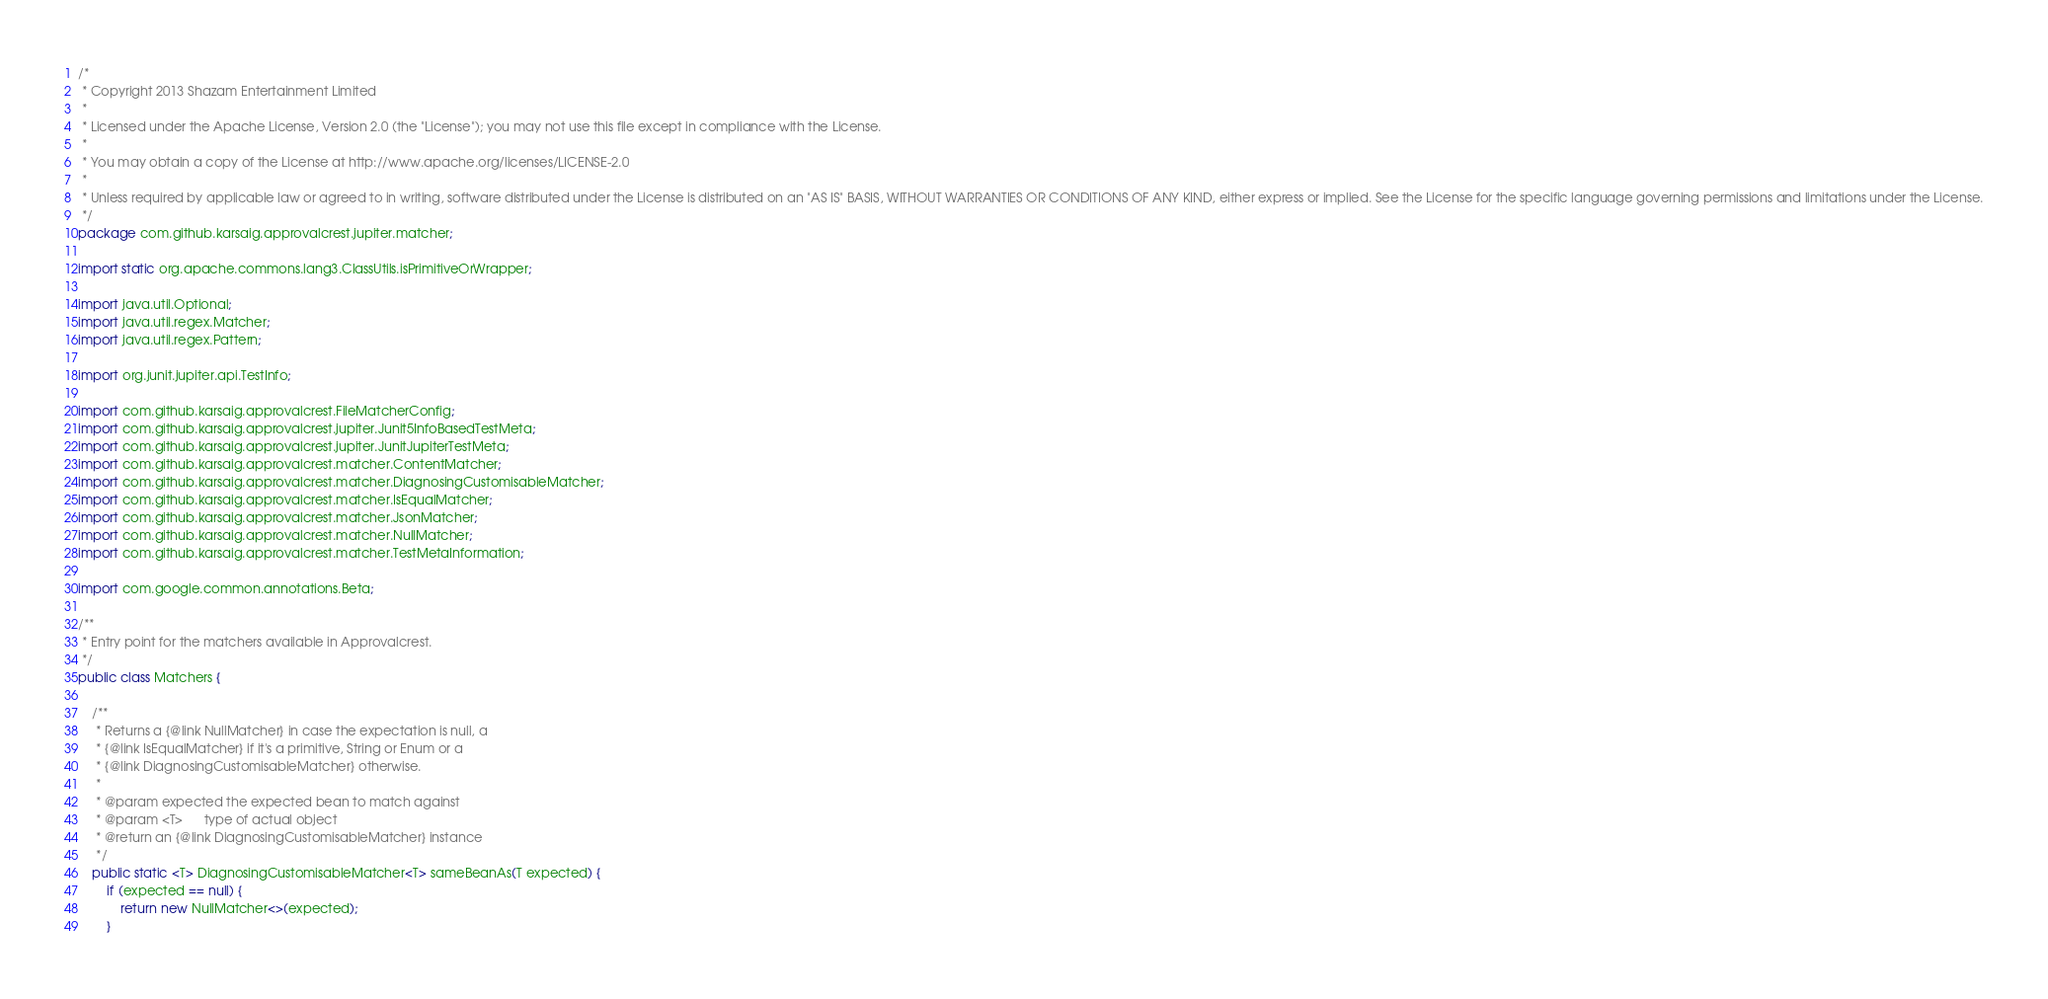<code> <loc_0><loc_0><loc_500><loc_500><_Java_>/*
 * Copyright 2013 Shazam Entertainment Limited
 *
 * Licensed under the Apache License, Version 2.0 (the "License"); you may not use this file except in compliance with the License.
 *
 * You may obtain a copy of the License at http://www.apache.org/licenses/LICENSE-2.0
 *
 * Unless required by applicable law or agreed to in writing, software distributed under the License is distributed on an "AS IS" BASIS, WITHOUT WARRANTIES OR CONDITIONS OF ANY KIND, either express or implied. See the License for the specific language governing permissions and limitations under the License.
 */
package com.github.karsaig.approvalcrest.jupiter.matcher;

import static org.apache.commons.lang3.ClassUtils.isPrimitiveOrWrapper;

import java.util.Optional;
import java.util.regex.Matcher;
import java.util.regex.Pattern;

import org.junit.jupiter.api.TestInfo;

import com.github.karsaig.approvalcrest.FileMatcherConfig;
import com.github.karsaig.approvalcrest.jupiter.Junit5InfoBasedTestMeta;
import com.github.karsaig.approvalcrest.jupiter.JunitJupiterTestMeta;
import com.github.karsaig.approvalcrest.matcher.ContentMatcher;
import com.github.karsaig.approvalcrest.matcher.DiagnosingCustomisableMatcher;
import com.github.karsaig.approvalcrest.matcher.IsEqualMatcher;
import com.github.karsaig.approvalcrest.matcher.JsonMatcher;
import com.github.karsaig.approvalcrest.matcher.NullMatcher;
import com.github.karsaig.approvalcrest.matcher.TestMetaInformation;

import com.google.common.annotations.Beta;

/**
 * Entry point for the matchers available in Approvalcrest.
 */
public class Matchers {

    /**
     * Returns a {@link NullMatcher} in case the expectation is null, a
     * {@link IsEqualMatcher} if it's a primitive, String or Enum or a
     * {@link DiagnosingCustomisableMatcher} otherwise.
     *
     * @param expected the expected bean to match against
     * @param <T>      type of actual object
     * @return an {@link DiagnosingCustomisableMatcher} instance
     */
    public static <T> DiagnosingCustomisableMatcher<T> sameBeanAs(T expected) {
        if (expected == null) {
            return new NullMatcher<>(expected);
        }
</code> 